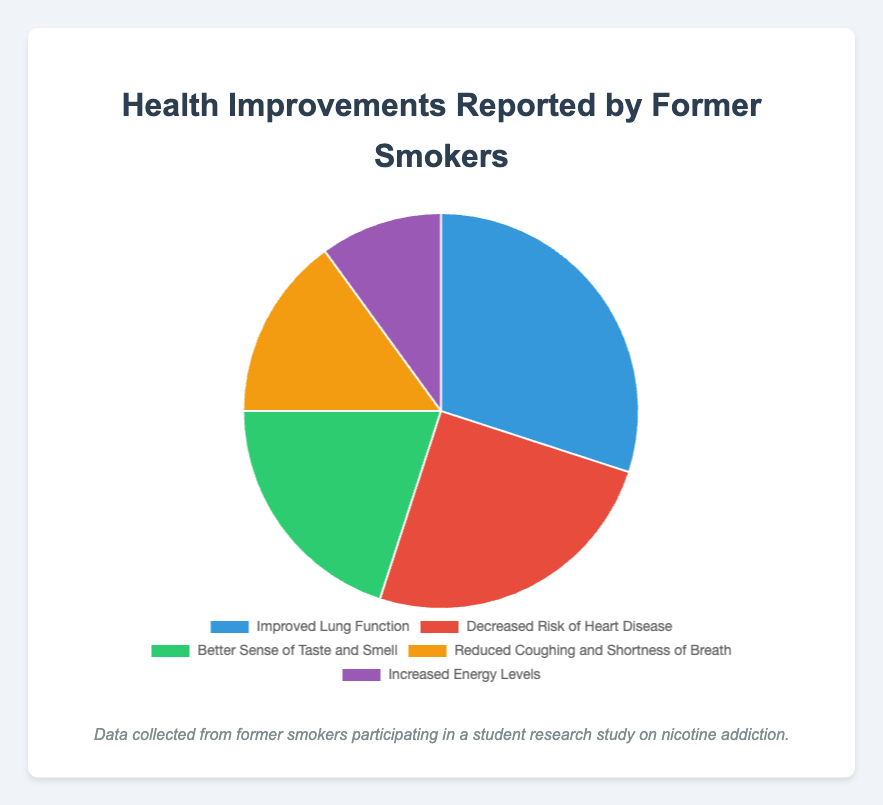What's the most frequently reported health improvement by former smokers? The most frequently reported health improvement is represented by the largest segment in the pie chart, which is "Improved Lung Function" with 30%.
Answer: Improved Lung Function Which health improvement has a higher percentage, "Decreased Risk of Heart Disease" or "Better Sense of Taste and Smell"? We compare the percentages for "Decreased Risk of Heart Disease" (25%) and "Better Sense of Taste and Smell" (20%). The former has a higher percentage.
Answer: Decreased Risk of Heart Disease What is the combined percentage of "Improved Lung Function" and "Increased Energy Levels"? Add the percentages of "Improved Lung Function" (30%) and "Increased Energy Levels" (10%). 30% + 10% = 40%.
Answer: 40% Which color segment represents "Reduced Coughing and Shortness of Breath"? The color representing "Reduced Coughing and Shortness of Breath" is yellow as per the visual attributes of the chart.
Answer: Yellow How much more prevalent is "Better Sense of Taste and Smell" compared to "Increased Energy Levels"? Subtract the percentage of "Increased Energy Levels" (10%) from "Better Sense of Taste and Smell" (20%). 20% - 10% = 10%.
Answer: 10% Rank the health improvements from most to least reported. The percentages in descending order are 30% (Improved Lung Function), 25% (Decreased Risk of Heart Disease), 20% (Better Sense of Taste and Smell), 15% (Reduced Coughing and Shortness of Breath), and 10% (Increased Energy Levels).
Answer: Improved Lung Function, Decreased Risk of Heart Disease, Better Sense of Taste and Smell, Reduced Coughing and Shortness of Breath, Increased Energy Levels Which two health improvements together constitute exactly half of the reported improvements? Combining "Improved Lung Function" (30%) and "Decreased Risk of Heart Disease" (25%) results in 55%, which exceeds 50%. The sum of "Decreased Risk of Heart Disease" (25%) and "Better Sense of Taste and Smell" (20%) is 45%, less than 50%. Thus "Improved Lung function" (30%) and "Reduced Coughing and Shortness of Breath" (15%) sums to exactly 45%, less than 50%. The sum of "Improved Lung Function" (30%) and "Better Sense of Taste and Smell" (20%) is 50%.
Answer: Improved Lung Function and Better Sense of Taste and Smell 